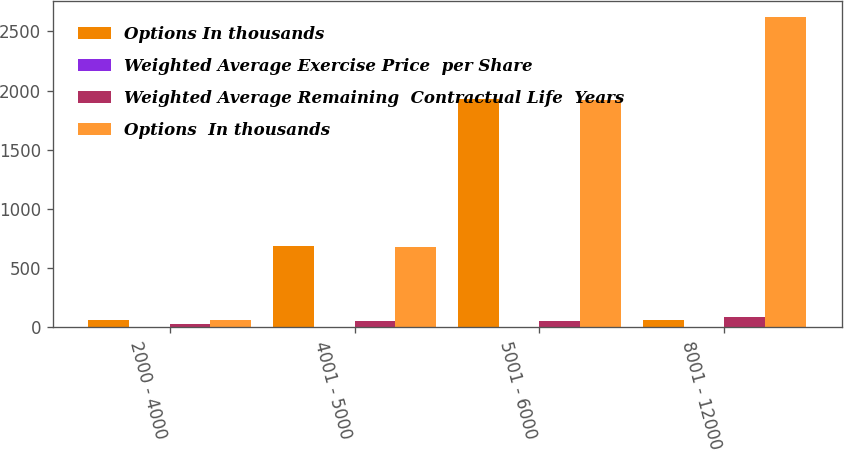Convert chart to OTSL. <chart><loc_0><loc_0><loc_500><loc_500><stacked_bar_chart><ecel><fcel>2000 - 4000<fcel>4001 - 5000<fcel>5001 - 6000<fcel>8001 - 12000<nl><fcel>Options In thousands<fcel>65<fcel>684<fcel>1927<fcel>65<nl><fcel>Weighted Average Exercise Price  per Share<fcel>1<fcel>2<fcel>4<fcel>5<nl><fcel>Weighted Average Remaining  Contractual Life  Years<fcel>29.96<fcel>49.42<fcel>55.08<fcel>82.85<nl><fcel>Options  In thousands<fcel>65<fcel>681<fcel>1921<fcel>2625<nl></chart> 